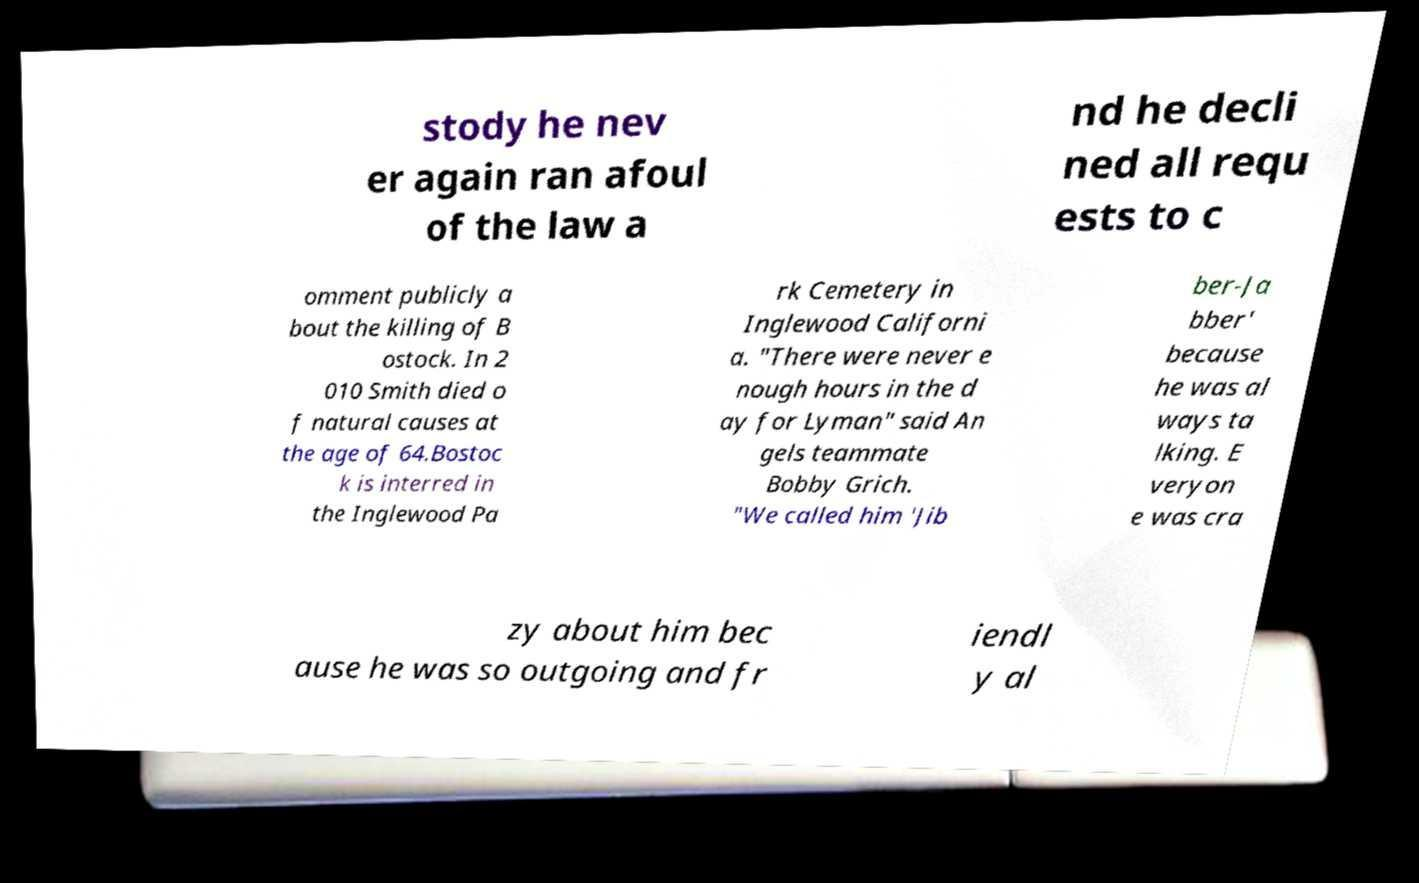There's text embedded in this image that I need extracted. Can you transcribe it verbatim? stody he nev er again ran afoul of the law a nd he decli ned all requ ests to c omment publicly a bout the killing of B ostock. In 2 010 Smith died o f natural causes at the age of 64.Bostoc k is interred in the Inglewood Pa rk Cemetery in Inglewood Californi a. "There were never e nough hours in the d ay for Lyman" said An gels teammate Bobby Grich. "We called him 'Jib ber-Ja bber' because he was al ways ta lking. E veryon e was cra zy about him bec ause he was so outgoing and fr iendl y al 